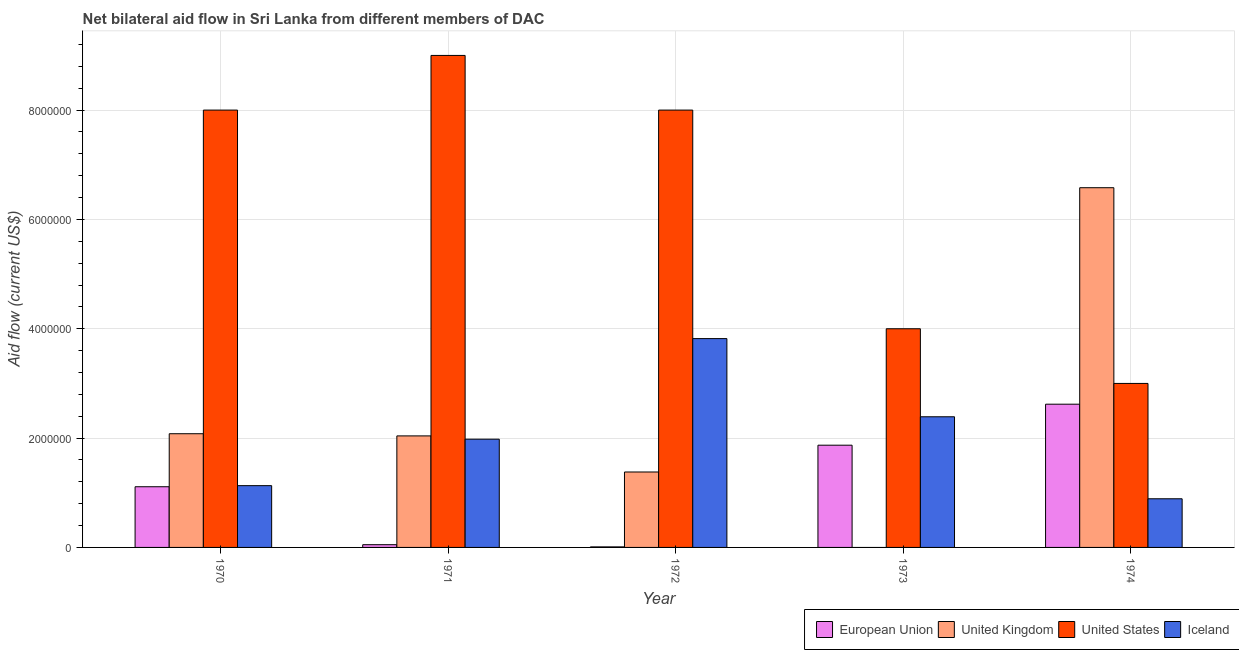Are the number of bars per tick equal to the number of legend labels?
Offer a terse response. No. How many bars are there on the 5th tick from the left?
Offer a very short reply. 4. What is the amount of aid given by us in 1972?
Your response must be concise. 8.00e+06. Across all years, what is the maximum amount of aid given by us?
Make the answer very short. 9.00e+06. Across all years, what is the minimum amount of aid given by us?
Make the answer very short. 3.00e+06. In which year was the amount of aid given by eu maximum?
Give a very brief answer. 1974. What is the total amount of aid given by uk in the graph?
Offer a terse response. 1.21e+07. What is the difference between the amount of aid given by eu in 1971 and the amount of aid given by uk in 1974?
Your response must be concise. -2.57e+06. What is the average amount of aid given by us per year?
Make the answer very short. 6.40e+06. In the year 1970, what is the difference between the amount of aid given by eu and amount of aid given by iceland?
Offer a terse response. 0. Is the amount of aid given by eu in 1973 less than that in 1974?
Provide a short and direct response. Yes. What is the difference between the highest and the second highest amount of aid given by eu?
Your response must be concise. 7.50e+05. What is the difference between the highest and the lowest amount of aid given by us?
Provide a short and direct response. 6.00e+06. Is it the case that in every year, the sum of the amount of aid given by eu and amount of aid given by uk is greater than the amount of aid given by us?
Provide a succinct answer. No. Are all the bars in the graph horizontal?
Give a very brief answer. No. What is the difference between two consecutive major ticks on the Y-axis?
Keep it short and to the point. 2.00e+06. Are the values on the major ticks of Y-axis written in scientific E-notation?
Offer a very short reply. No. Where does the legend appear in the graph?
Make the answer very short. Bottom right. How many legend labels are there?
Offer a very short reply. 4. How are the legend labels stacked?
Keep it short and to the point. Horizontal. What is the title of the graph?
Offer a very short reply. Net bilateral aid flow in Sri Lanka from different members of DAC. Does "Social Assistance" appear as one of the legend labels in the graph?
Give a very brief answer. No. What is the label or title of the Y-axis?
Offer a very short reply. Aid flow (current US$). What is the Aid flow (current US$) of European Union in 1970?
Provide a short and direct response. 1.11e+06. What is the Aid flow (current US$) of United Kingdom in 1970?
Your answer should be compact. 2.08e+06. What is the Aid flow (current US$) of United States in 1970?
Keep it short and to the point. 8.00e+06. What is the Aid flow (current US$) of Iceland in 1970?
Offer a terse response. 1.13e+06. What is the Aid flow (current US$) in United Kingdom in 1971?
Your answer should be compact. 2.04e+06. What is the Aid flow (current US$) of United States in 1971?
Your answer should be compact. 9.00e+06. What is the Aid flow (current US$) in Iceland in 1971?
Ensure brevity in your answer.  1.98e+06. What is the Aid flow (current US$) in United Kingdom in 1972?
Your answer should be very brief. 1.38e+06. What is the Aid flow (current US$) in Iceland in 1972?
Your answer should be compact. 3.82e+06. What is the Aid flow (current US$) of European Union in 1973?
Give a very brief answer. 1.87e+06. What is the Aid flow (current US$) in United Kingdom in 1973?
Your answer should be compact. 0. What is the Aid flow (current US$) in Iceland in 1973?
Keep it short and to the point. 2.39e+06. What is the Aid flow (current US$) of European Union in 1974?
Your response must be concise. 2.62e+06. What is the Aid flow (current US$) in United Kingdom in 1974?
Keep it short and to the point. 6.58e+06. What is the Aid flow (current US$) of Iceland in 1974?
Offer a very short reply. 8.90e+05. Across all years, what is the maximum Aid flow (current US$) in European Union?
Your answer should be very brief. 2.62e+06. Across all years, what is the maximum Aid flow (current US$) in United Kingdom?
Your answer should be compact. 6.58e+06. Across all years, what is the maximum Aid flow (current US$) of United States?
Make the answer very short. 9.00e+06. Across all years, what is the maximum Aid flow (current US$) of Iceland?
Ensure brevity in your answer.  3.82e+06. Across all years, what is the minimum Aid flow (current US$) of United Kingdom?
Offer a terse response. 0. Across all years, what is the minimum Aid flow (current US$) in Iceland?
Ensure brevity in your answer.  8.90e+05. What is the total Aid flow (current US$) of European Union in the graph?
Provide a short and direct response. 5.66e+06. What is the total Aid flow (current US$) in United Kingdom in the graph?
Make the answer very short. 1.21e+07. What is the total Aid flow (current US$) in United States in the graph?
Make the answer very short. 3.20e+07. What is the total Aid flow (current US$) in Iceland in the graph?
Offer a terse response. 1.02e+07. What is the difference between the Aid flow (current US$) in European Union in 1970 and that in 1971?
Your response must be concise. 1.06e+06. What is the difference between the Aid flow (current US$) of United States in 1970 and that in 1971?
Make the answer very short. -1.00e+06. What is the difference between the Aid flow (current US$) of Iceland in 1970 and that in 1971?
Offer a very short reply. -8.50e+05. What is the difference between the Aid flow (current US$) in European Union in 1970 and that in 1972?
Your response must be concise. 1.10e+06. What is the difference between the Aid flow (current US$) of United Kingdom in 1970 and that in 1972?
Offer a terse response. 7.00e+05. What is the difference between the Aid flow (current US$) of Iceland in 1970 and that in 1972?
Give a very brief answer. -2.69e+06. What is the difference between the Aid flow (current US$) of European Union in 1970 and that in 1973?
Offer a terse response. -7.60e+05. What is the difference between the Aid flow (current US$) in United States in 1970 and that in 1973?
Make the answer very short. 4.00e+06. What is the difference between the Aid flow (current US$) in Iceland in 1970 and that in 1973?
Your answer should be very brief. -1.26e+06. What is the difference between the Aid flow (current US$) in European Union in 1970 and that in 1974?
Offer a terse response. -1.51e+06. What is the difference between the Aid flow (current US$) in United Kingdom in 1970 and that in 1974?
Provide a short and direct response. -4.50e+06. What is the difference between the Aid flow (current US$) of European Union in 1971 and that in 1972?
Give a very brief answer. 4.00e+04. What is the difference between the Aid flow (current US$) of Iceland in 1971 and that in 1972?
Offer a very short reply. -1.84e+06. What is the difference between the Aid flow (current US$) in European Union in 1971 and that in 1973?
Your answer should be very brief. -1.82e+06. What is the difference between the Aid flow (current US$) of United States in 1971 and that in 1973?
Your answer should be very brief. 5.00e+06. What is the difference between the Aid flow (current US$) in Iceland in 1971 and that in 1973?
Offer a terse response. -4.10e+05. What is the difference between the Aid flow (current US$) of European Union in 1971 and that in 1974?
Your answer should be compact. -2.57e+06. What is the difference between the Aid flow (current US$) of United Kingdom in 1971 and that in 1974?
Keep it short and to the point. -4.54e+06. What is the difference between the Aid flow (current US$) in Iceland in 1971 and that in 1974?
Offer a very short reply. 1.09e+06. What is the difference between the Aid flow (current US$) in European Union in 1972 and that in 1973?
Make the answer very short. -1.86e+06. What is the difference between the Aid flow (current US$) of Iceland in 1972 and that in 1973?
Offer a very short reply. 1.43e+06. What is the difference between the Aid flow (current US$) of European Union in 1972 and that in 1974?
Provide a short and direct response. -2.61e+06. What is the difference between the Aid flow (current US$) of United Kingdom in 1972 and that in 1974?
Your answer should be very brief. -5.20e+06. What is the difference between the Aid flow (current US$) in United States in 1972 and that in 1974?
Keep it short and to the point. 5.00e+06. What is the difference between the Aid flow (current US$) in Iceland in 1972 and that in 1974?
Your answer should be very brief. 2.93e+06. What is the difference between the Aid flow (current US$) of European Union in 1973 and that in 1974?
Make the answer very short. -7.50e+05. What is the difference between the Aid flow (current US$) in Iceland in 1973 and that in 1974?
Your response must be concise. 1.50e+06. What is the difference between the Aid flow (current US$) in European Union in 1970 and the Aid flow (current US$) in United Kingdom in 1971?
Offer a very short reply. -9.30e+05. What is the difference between the Aid flow (current US$) of European Union in 1970 and the Aid flow (current US$) of United States in 1971?
Make the answer very short. -7.89e+06. What is the difference between the Aid flow (current US$) of European Union in 1970 and the Aid flow (current US$) of Iceland in 1971?
Provide a short and direct response. -8.70e+05. What is the difference between the Aid flow (current US$) in United Kingdom in 1970 and the Aid flow (current US$) in United States in 1971?
Ensure brevity in your answer.  -6.92e+06. What is the difference between the Aid flow (current US$) of United States in 1970 and the Aid flow (current US$) of Iceland in 1971?
Offer a very short reply. 6.02e+06. What is the difference between the Aid flow (current US$) of European Union in 1970 and the Aid flow (current US$) of United Kingdom in 1972?
Your answer should be very brief. -2.70e+05. What is the difference between the Aid flow (current US$) of European Union in 1970 and the Aid flow (current US$) of United States in 1972?
Provide a succinct answer. -6.89e+06. What is the difference between the Aid flow (current US$) of European Union in 1970 and the Aid flow (current US$) of Iceland in 1972?
Your answer should be very brief. -2.71e+06. What is the difference between the Aid flow (current US$) in United Kingdom in 1970 and the Aid flow (current US$) in United States in 1972?
Ensure brevity in your answer.  -5.92e+06. What is the difference between the Aid flow (current US$) of United Kingdom in 1970 and the Aid flow (current US$) of Iceland in 1972?
Give a very brief answer. -1.74e+06. What is the difference between the Aid flow (current US$) in United States in 1970 and the Aid flow (current US$) in Iceland in 1972?
Offer a terse response. 4.18e+06. What is the difference between the Aid flow (current US$) in European Union in 1970 and the Aid flow (current US$) in United States in 1973?
Your response must be concise. -2.89e+06. What is the difference between the Aid flow (current US$) in European Union in 1970 and the Aid flow (current US$) in Iceland in 1973?
Ensure brevity in your answer.  -1.28e+06. What is the difference between the Aid flow (current US$) of United Kingdom in 1970 and the Aid flow (current US$) of United States in 1973?
Your answer should be very brief. -1.92e+06. What is the difference between the Aid flow (current US$) of United Kingdom in 1970 and the Aid flow (current US$) of Iceland in 1973?
Provide a succinct answer. -3.10e+05. What is the difference between the Aid flow (current US$) in United States in 1970 and the Aid flow (current US$) in Iceland in 1973?
Offer a very short reply. 5.61e+06. What is the difference between the Aid flow (current US$) of European Union in 1970 and the Aid flow (current US$) of United Kingdom in 1974?
Offer a very short reply. -5.47e+06. What is the difference between the Aid flow (current US$) in European Union in 1970 and the Aid flow (current US$) in United States in 1974?
Your response must be concise. -1.89e+06. What is the difference between the Aid flow (current US$) of United Kingdom in 1970 and the Aid flow (current US$) of United States in 1974?
Your answer should be compact. -9.20e+05. What is the difference between the Aid flow (current US$) in United Kingdom in 1970 and the Aid flow (current US$) in Iceland in 1974?
Offer a very short reply. 1.19e+06. What is the difference between the Aid flow (current US$) in United States in 1970 and the Aid flow (current US$) in Iceland in 1974?
Provide a succinct answer. 7.11e+06. What is the difference between the Aid flow (current US$) in European Union in 1971 and the Aid flow (current US$) in United Kingdom in 1972?
Keep it short and to the point. -1.33e+06. What is the difference between the Aid flow (current US$) of European Union in 1971 and the Aid flow (current US$) of United States in 1972?
Your answer should be compact. -7.95e+06. What is the difference between the Aid flow (current US$) of European Union in 1971 and the Aid flow (current US$) of Iceland in 1972?
Offer a terse response. -3.77e+06. What is the difference between the Aid flow (current US$) in United Kingdom in 1971 and the Aid flow (current US$) in United States in 1972?
Ensure brevity in your answer.  -5.96e+06. What is the difference between the Aid flow (current US$) in United Kingdom in 1971 and the Aid flow (current US$) in Iceland in 1972?
Your answer should be very brief. -1.78e+06. What is the difference between the Aid flow (current US$) in United States in 1971 and the Aid flow (current US$) in Iceland in 1972?
Give a very brief answer. 5.18e+06. What is the difference between the Aid flow (current US$) of European Union in 1971 and the Aid flow (current US$) of United States in 1973?
Your response must be concise. -3.95e+06. What is the difference between the Aid flow (current US$) in European Union in 1971 and the Aid flow (current US$) in Iceland in 1973?
Your answer should be compact. -2.34e+06. What is the difference between the Aid flow (current US$) of United Kingdom in 1971 and the Aid flow (current US$) of United States in 1973?
Provide a short and direct response. -1.96e+06. What is the difference between the Aid flow (current US$) in United Kingdom in 1971 and the Aid flow (current US$) in Iceland in 1973?
Your answer should be very brief. -3.50e+05. What is the difference between the Aid flow (current US$) of United States in 1971 and the Aid flow (current US$) of Iceland in 1973?
Give a very brief answer. 6.61e+06. What is the difference between the Aid flow (current US$) in European Union in 1971 and the Aid flow (current US$) in United Kingdom in 1974?
Offer a very short reply. -6.53e+06. What is the difference between the Aid flow (current US$) of European Union in 1971 and the Aid flow (current US$) of United States in 1974?
Offer a terse response. -2.95e+06. What is the difference between the Aid flow (current US$) of European Union in 1971 and the Aid flow (current US$) of Iceland in 1974?
Give a very brief answer. -8.40e+05. What is the difference between the Aid flow (current US$) of United Kingdom in 1971 and the Aid flow (current US$) of United States in 1974?
Ensure brevity in your answer.  -9.60e+05. What is the difference between the Aid flow (current US$) of United Kingdom in 1971 and the Aid flow (current US$) of Iceland in 1974?
Provide a succinct answer. 1.15e+06. What is the difference between the Aid flow (current US$) in United States in 1971 and the Aid flow (current US$) in Iceland in 1974?
Ensure brevity in your answer.  8.11e+06. What is the difference between the Aid flow (current US$) in European Union in 1972 and the Aid flow (current US$) in United States in 1973?
Your answer should be very brief. -3.99e+06. What is the difference between the Aid flow (current US$) in European Union in 1972 and the Aid flow (current US$) in Iceland in 1973?
Ensure brevity in your answer.  -2.38e+06. What is the difference between the Aid flow (current US$) in United Kingdom in 1972 and the Aid flow (current US$) in United States in 1973?
Keep it short and to the point. -2.62e+06. What is the difference between the Aid flow (current US$) of United Kingdom in 1972 and the Aid flow (current US$) of Iceland in 1973?
Your response must be concise. -1.01e+06. What is the difference between the Aid flow (current US$) in United States in 1972 and the Aid flow (current US$) in Iceland in 1973?
Offer a very short reply. 5.61e+06. What is the difference between the Aid flow (current US$) in European Union in 1972 and the Aid flow (current US$) in United Kingdom in 1974?
Provide a succinct answer. -6.57e+06. What is the difference between the Aid flow (current US$) in European Union in 1972 and the Aid flow (current US$) in United States in 1974?
Offer a very short reply. -2.99e+06. What is the difference between the Aid flow (current US$) in European Union in 1972 and the Aid flow (current US$) in Iceland in 1974?
Keep it short and to the point. -8.80e+05. What is the difference between the Aid flow (current US$) in United Kingdom in 1972 and the Aid flow (current US$) in United States in 1974?
Offer a very short reply. -1.62e+06. What is the difference between the Aid flow (current US$) in United Kingdom in 1972 and the Aid flow (current US$) in Iceland in 1974?
Your answer should be compact. 4.90e+05. What is the difference between the Aid flow (current US$) of United States in 1972 and the Aid flow (current US$) of Iceland in 1974?
Make the answer very short. 7.11e+06. What is the difference between the Aid flow (current US$) of European Union in 1973 and the Aid flow (current US$) of United Kingdom in 1974?
Ensure brevity in your answer.  -4.71e+06. What is the difference between the Aid flow (current US$) of European Union in 1973 and the Aid flow (current US$) of United States in 1974?
Your response must be concise. -1.13e+06. What is the difference between the Aid flow (current US$) of European Union in 1973 and the Aid flow (current US$) of Iceland in 1974?
Your answer should be compact. 9.80e+05. What is the difference between the Aid flow (current US$) of United States in 1973 and the Aid flow (current US$) of Iceland in 1974?
Keep it short and to the point. 3.11e+06. What is the average Aid flow (current US$) of European Union per year?
Your answer should be very brief. 1.13e+06. What is the average Aid flow (current US$) in United Kingdom per year?
Your answer should be compact. 2.42e+06. What is the average Aid flow (current US$) in United States per year?
Provide a short and direct response. 6.40e+06. What is the average Aid flow (current US$) in Iceland per year?
Provide a short and direct response. 2.04e+06. In the year 1970, what is the difference between the Aid flow (current US$) in European Union and Aid flow (current US$) in United Kingdom?
Your response must be concise. -9.70e+05. In the year 1970, what is the difference between the Aid flow (current US$) in European Union and Aid flow (current US$) in United States?
Provide a short and direct response. -6.89e+06. In the year 1970, what is the difference between the Aid flow (current US$) in United Kingdom and Aid flow (current US$) in United States?
Give a very brief answer. -5.92e+06. In the year 1970, what is the difference between the Aid flow (current US$) in United Kingdom and Aid flow (current US$) in Iceland?
Give a very brief answer. 9.50e+05. In the year 1970, what is the difference between the Aid flow (current US$) in United States and Aid flow (current US$) in Iceland?
Offer a very short reply. 6.87e+06. In the year 1971, what is the difference between the Aid flow (current US$) of European Union and Aid flow (current US$) of United Kingdom?
Keep it short and to the point. -1.99e+06. In the year 1971, what is the difference between the Aid flow (current US$) of European Union and Aid flow (current US$) of United States?
Give a very brief answer. -8.95e+06. In the year 1971, what is the difference between the Aid flow (current US$) in European Union and Aid flow (current US$) in Iceland?
Ensure brevity in your answer.  -1.93e+06. In the year 1971, what is the difference between the Aid flow (current US$) in United Kingdom and Aid flow (current US$) in United States?
Offer a very short reply. -6.96e+06. In the year 1971, what is the difference between the Aid flow (current US$) in United States and Aid flow (current US$) in Iceland?
Offer a very short reply. 7.02e+06. In the year 1972, what is the difference between the Aid flow (current US$) in European Union and Aid flow (current US$) in United Kingdom?
Your answer should be very brief. -1.37e+06. In the year 1972, what is the difference between the Aid flow (current US$) of European Union and Aid flow (current US$) of United States?
Provide a short and direct response. -7.99e+06. In the year 1972, what is the difference between the Aid flow (current US$) in European Union and Aid flow (current US$) in Iceland?
Provide a short and direct response. -3.81e+06. In the year 1972, what is the difference between the Aid flow (current US$) of United Kingdom and Aid flow (current US$) of United States?
Provide a succinct answer. -6.62e+06. In the year 1972, what is the difference between the Aid flow (current US$) in United Kingdom and Aid flow (current US$) in Iceland?
Offer a very short reply. -2.44e+06. In the year 1972, what is the difference between the Aid flow (current US$) of United States and Aid flow (current US$) of Iceland?
Offer a terse response. 4.18e+06. In the year 1973, what is the difference between the Aid flow (current US$) of European Union and Aid flow (current US$) of United States?
Give a very brief answer. -2.13e+06. In the year 1973, what is the difference between the Aid flow (current US$) of European Union and Aid flow (current US$) of Iceland?
Keep it short and to the point. -5.20e+05. In the year 1973, what is the difference between the Aid flow (current US$) in United States and Aid flow (current US$) in Iceland?
Your answer should be compact. 1.61e+06. In the year 1974, what is the difference between the Aid flow (current US$) of European Union and Aid flow (current US$) of United Kingdom?
Offer a very short reply. -3.96e+06. In the year 1974, what is the difference between the Aid flow (current US$) of European Union and Aid flow (current US$) of United States?
Provide a short and direct response. -3.80e+05. In the year 1974, what is the difference between the Aid flow (current US$) in European Union and Aid flow (current US$) in Iceland?
Make the answer very short. 1.73e+06. In the year 1974, what is the difference between the Aid flow (current US$) in United Kingdom and Aid flow (current US$) in United States?
Offer a very short reply. 3.58e+06. In the year 1974, what is the difference between the Aid flow (current US$) in United Kingdom and Aid flow (current US$) in Iceland?
Your response must be concise. 5.69e+06. In the year 1974, what is the difference between the Aid flow (current US$) in United States and Aid flow (current US$) in Iceland?
Your answer should be very brief. 2.11e+06. What is the ratio of the Aid flow (current US$) of European Union in 1970 to that in 1971?
Provide a succinct answer. 22.2. What is the ratio of the Aid flow (current US$) in United Kingdom in 1970 to that in 1971?
Your answer should be compact. 1.02. What is the ratio of the Aid flow (current US$) of Iceland in 1970 to that in 1971?
Your response must be concise. 0.57. What is the ratio of the Aid flow (current US$) in European Union in 1970 to that in 1972?
Keep it short and to the point. 111. What is the ratio of the Aid flow (current US$) of United Kingdom in 1970 to that in 1972?
Provide a succinct answer. 1.51. What is the ratio of the Aid flow (current US$) of United States in 1970 to that in 1972?
Provide a short and direct response. 1. What is the ratio of the Aid flow (current US$) of Iceland in 1970 to that in 1972?
Provide a short and direct response. 0.3. What is the ratio of the Aid flow (current US$) in European Union in 1970 to that in 1973?
Provide a succinct answer. 0.59. What is the ratio of the Aid flow (current US$) in United States in 1970 to that in 1973?
Provide a succinct answer. 2. What is the ratio of the Aid flow (current US$) in Iceland in 1970 to that in 1973?
Your answer should be very brief. 0.47. What is the ratio of the Aid flow (current US$) of European Union in 1970 to that in 1974?
Give a very brief answer. 0.42. What is the ratio of the Aid flow (current US$) of United Kingdom in 1970 to that in 1974?
Your answer should be compact. 0.32. What is the ratio of the Aid flow (current US$) of United States in 1970 to that in 1974?
Keep it short and to the point. 2.67. What is the ratio of the Aid flow (current US$) of Iceland in 1970 to that in 1974?
Offer a very short reply. 1.27. What is the ratio of the Aid flow (current US$) in European Union in 1971 to that in 1972?
Your answer should be compact. 5. What is the ratio of the Aid flow (current US$) of United Kingdom in 1971 to that in 1972?
Provide a succinct answer. 1.48. What is the ratio of the Aid flow (current US$) in United States in 1971 to that in 1972?
Ensure brevity in your answer.  1.12. What is the ratio of the Aid flow (current US$) in Iceland in 1971 to that in 1972?
Your answer should be very brief. 0.52. What is the ratio of the Aid flow (current US$) in European Union in 1971 to that in 1973?
Provide a succinct answer. 0.03. What is the ratio of the Aid flow (current US$) in United States in 1971 to that in 1973?
Give a very brief answer. 2.25. What is the ratio of the Aid flow (current US$) of Iceland in 1971 to that in 1973?
Ensure brevity in your answer.  0.83. What is the ratio of the Aid flow (current US$) of European Union in 1971 to that in 1974?
Provide a short and direct response. 0.02. What is the ratio of the Aid flow (current US$) of United Kingdom in 1971 to that in 1974?
Ensure brevity in your answer.  0.31. What is the ratio of the Aid flow (current US$) of United States in 1971 to that in 1974?
Keep it short and to the point. 3. What is the ratio of the Aid flow (current US$) in Iceland in 1971 to that in 1974?
Ensure brevity in your answer.  2.22. What is the ratio of the Aid flow (current US$) in European Union in 1972 to that in 1973?
Make the answer very short. 0.01. What is the ratio of the Aid flow (current US$) in Iceland in 1972 to that in 1973?
Offer a very short reply. 1.6. What is the ratio of the Aid flow (current US$) of European Union in 1972 to that in 1974?
Ensure brevity in your answer.  0. What is the ratio of the Aid flow (current US$) of United Kingdom in 1972 to that in 1974?
Provide a succinct answer. 0.21. What is the ratio of the Aid flow (current US$) of United States in 1972 to that in 1974?
Provide a succinct answer. 2.67. What is the ratio of the Aid flow (current US$) in Iceland in 1972 to that in 1974?
Ensure brevity in your answer.  4.29. What is the ratio of the Aid flow (current US$) of European Union in 1973 to that in 1974?
Your response must be concise. 0.71. What is the ratio of the Aid flow (current US$) in Iceland in 1973 to that in 1974?
Your answer should be compact. 2.69. What is the difference between the highest and the second highest Aid flow (current US$) in European Union?
Make the answer very short. 7.50e+05. What is the difference between the highest and the second highest Aid flow (current US$) of United Kingdom?
Your answer should be very brief. 4.50e+06. What is the difference between the highest and the second highest Aid flow (current US$) of Iceland?
Ensure brevity in your answer.  1.43e+06. What is the difference between the highest and the lowest Aid flow (current US$) in European Union?
Offer a terse response. 2.61e+06. What is the difference between the highest and the lowest Aid flow (current US$) of United Kingdom?
Make the answer very short. 6.58e+06. What is the difference between the highest and the lowest Aid flow (current US$) of United States?
Offer a terse response. 6.00e+06. What is the difference between the highest and the lowest Aid flow (current US$) in Iceland?
Provide a succinct answer. 2.93e+06. 